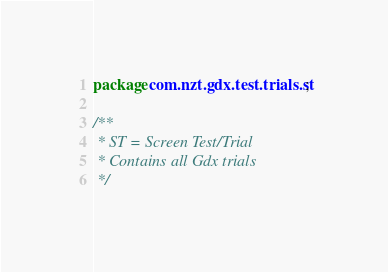Convert code to text. <code><loc_0><loc_0><loc_500><loc_500><_Java_>package com.nzt.gdx.test.trials.st;

/**
 * ST = Screen Test/Trial
 * Contains all Gdx trials
 */
</code> 